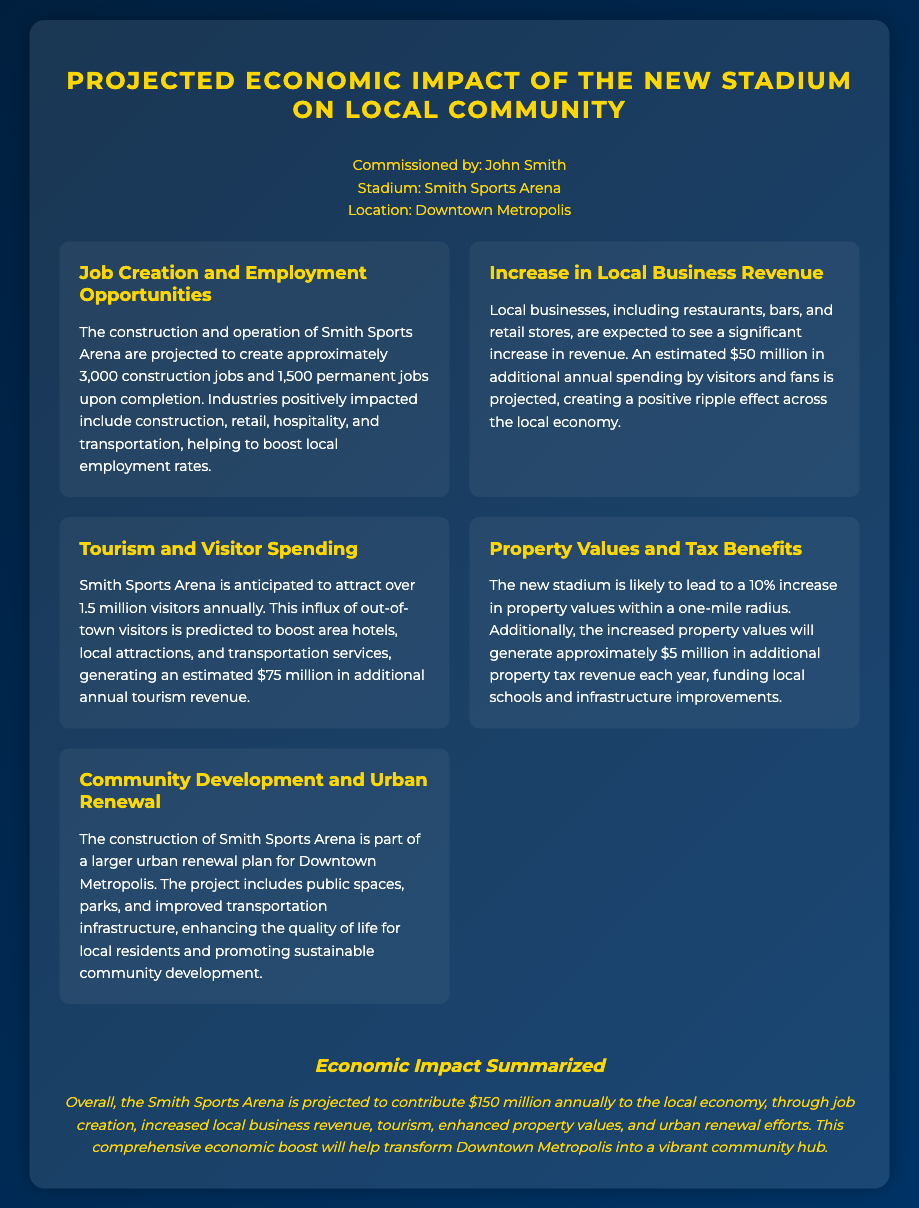What is the projected number of construction jobs? The document states that the construction of Smith Sports Arena is projected to create approximately 3,000 construction jobs.
Answer: 3,000 What is the estimated annual spending increase by visitors? It mentions that an estimated $50 million in additional annual spending by visitors and fans is projected.
Answer: $50 million How many permanent jobs will be created? The fact sheet indicates that 1,500 permanent jobs are expected upon completion of the stadium.
Answer: 1,500 What is the anticipated annual tourism revenue? The document predicts that the influx of visitors will generate an estimated $75 million in additional annual tourism revenue.
Answer: $75 million What percentage increase in property values is expected? A 10% increase in property values within a one-mile radius is mentioned in the document.
Answer: 10% What is the total projected contribution to the local economy? The summary states that the Smith Sports Arena is projected to contribute $150 million annually to the local economy.
Answer: $150 million What will the increased property values generate in additional tax revenue? The document indicates that approximately $5 million in additional property tax revenue will be generated each year.
Answer: $5 million What kind of urban development project is this stadium part of? It is part of a larger urban renewal plan for Downtown Metropolis.
Answer: Urban renewal How many visitors is the stadium expected to attract annually? The projected number of visitors is over 1.5 million annually.
Answer: 1.5 million What industries will benefit from the new stadium? The affected industries include construction, retail, hospitality, and transportation.
Answer: Construction, retail, hospitality, and transportation 